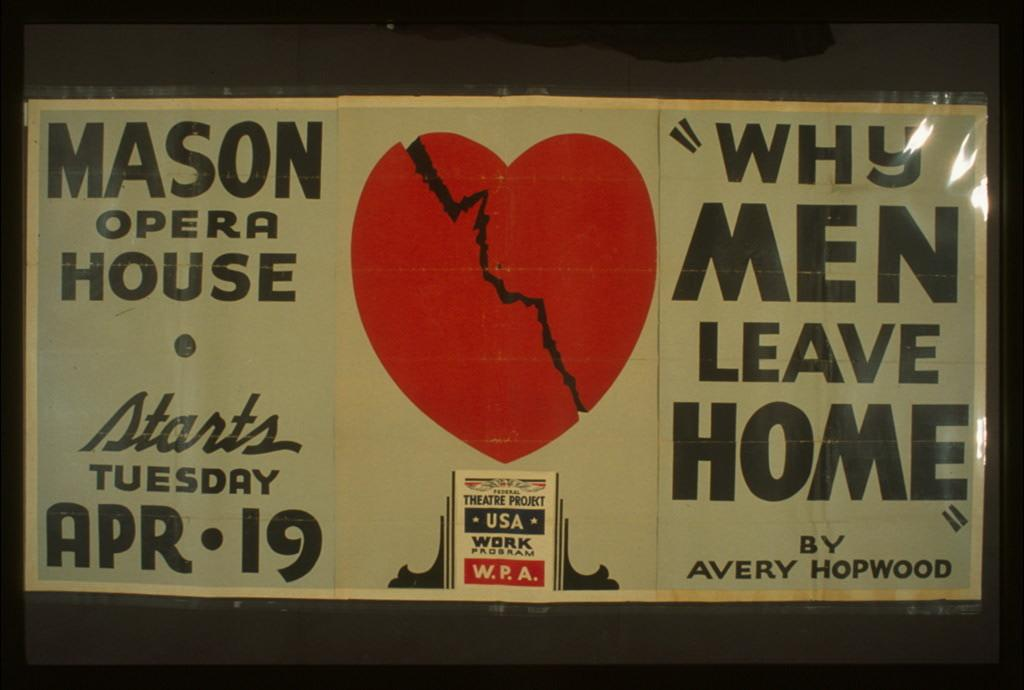Provide a one-sentence caption for the provided image. A sign for Mason Opera House starts Tuesday, April 19 with a heart broken in half and a quote of "why men leave home" by avery hopwood. 